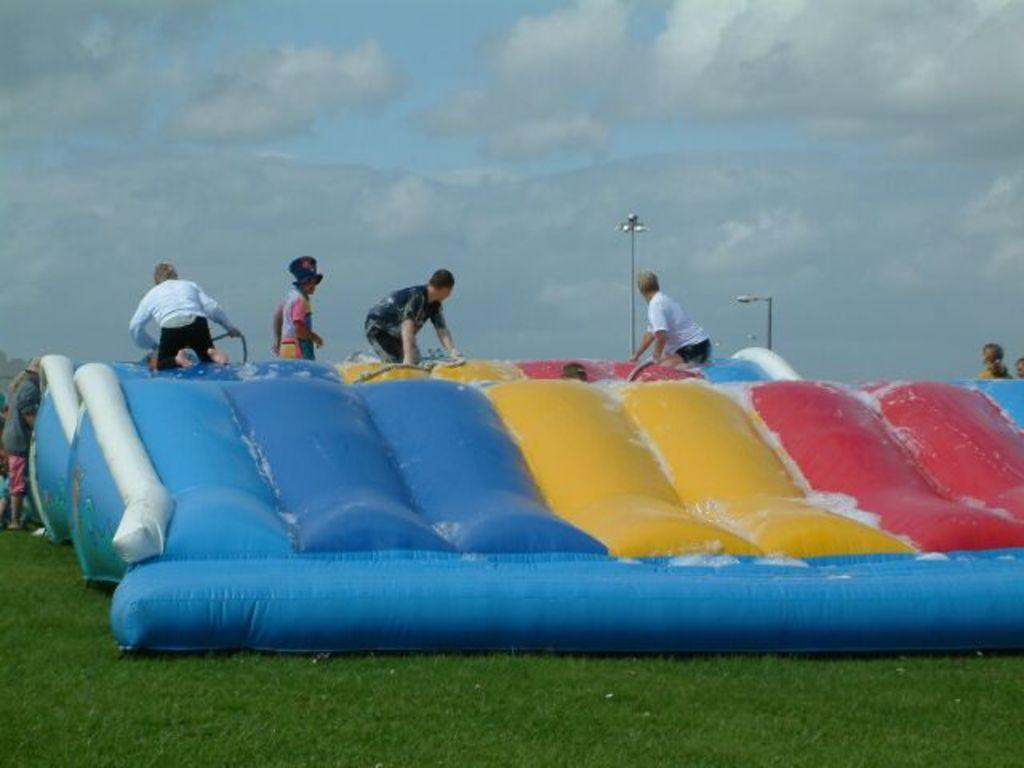What is the main object in the image? There is an inflatable in the image. What are the people on the inflatable doing? People are on the inflatable. What are the people wearing? The people are wearing clothes. What can be seen in the background of the image? There is a light pole and grass visible in the image. How would you describe the weather based on the image? The sky is cloudy in the image. What type of baseball game is being played on the seashore in the image? There is no baseball game or seashore present in the image; it features an inflatable with people on it. 